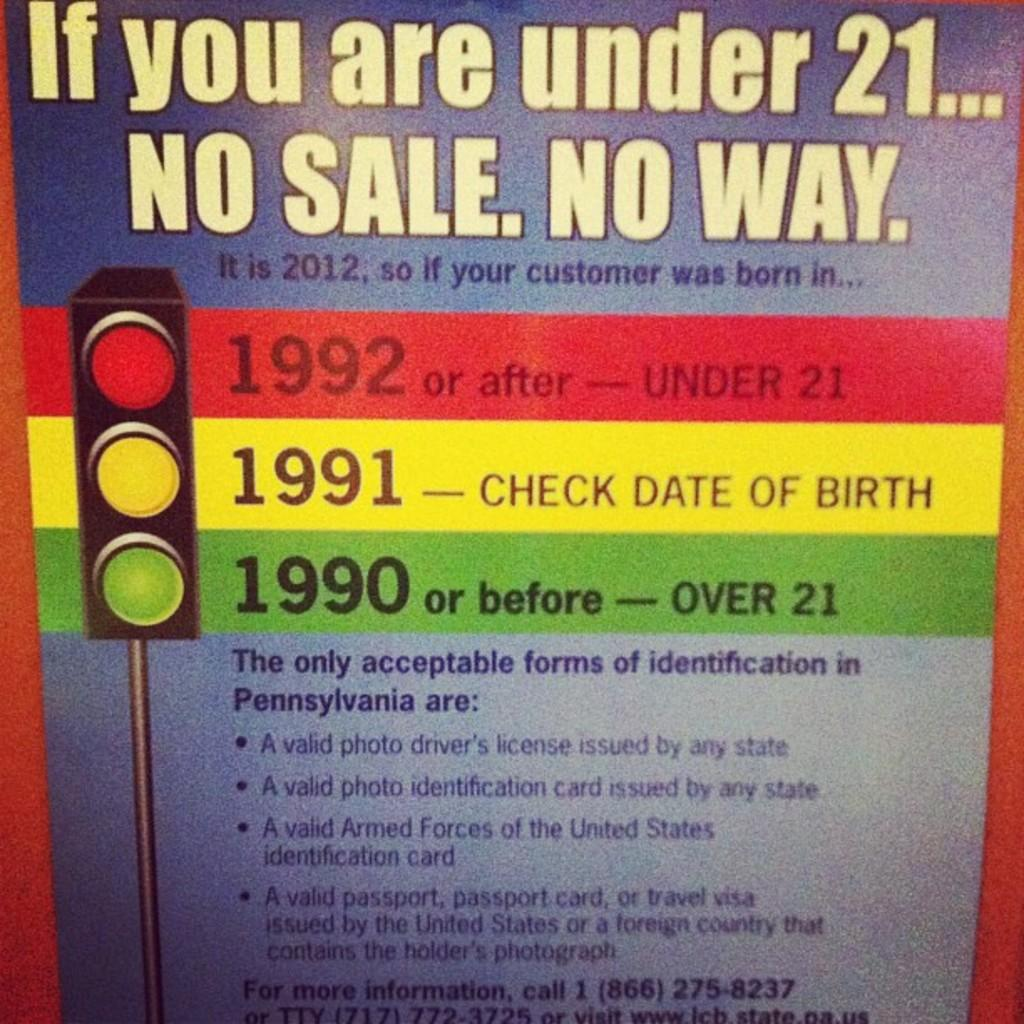<image>
Give a short and clear explanation of the subsequent image. The year you must have been born after to purchase alcohol. 